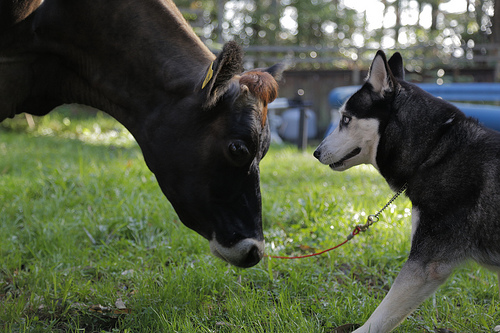<image>
Is the cow on the dog? No. The cow is not positioned on the dog. They may be near each other, but the cow is not supported by or resting on top of the dog. Where is the dog in relation to the cow? Is it in front of the cow? Yes. The dog is positioned in front of the cow, appearing closer to the camera viewpoint. Is the dog to the left of the cow? No. The dog is not to the left of the cow. From this viewpoint, they have a different horizontal relationship. 